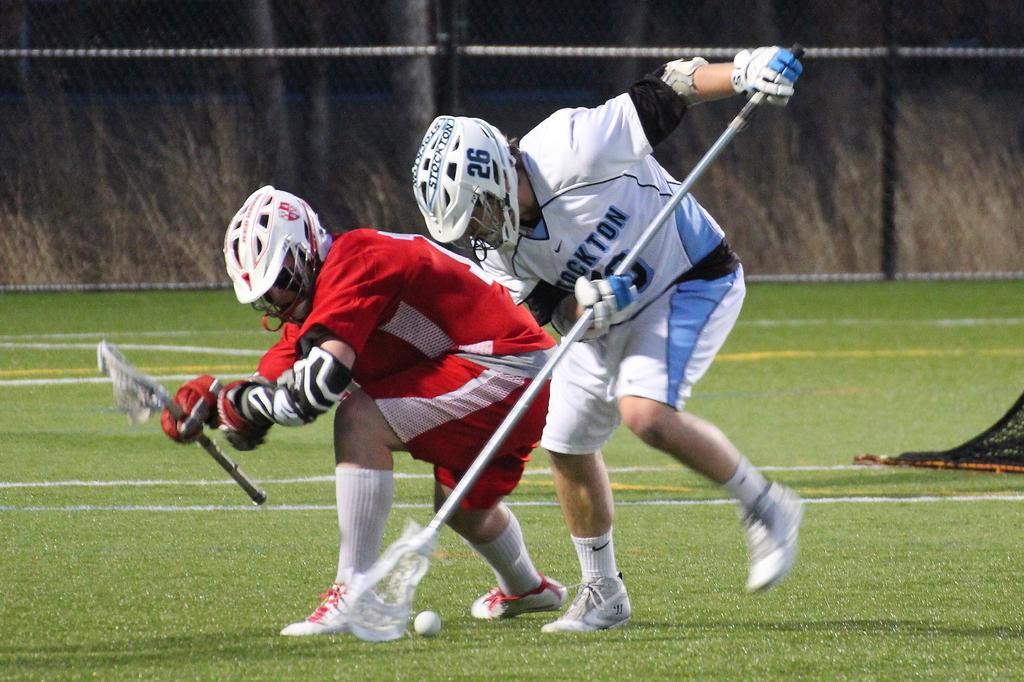In one or two sentences, can you explain what this image depicts? In this picture I can observe two members playing field lacrosse. They are wearing red and white color jerseys. Both of them are wearing helmets on their heads. In the background I can observe fence. 